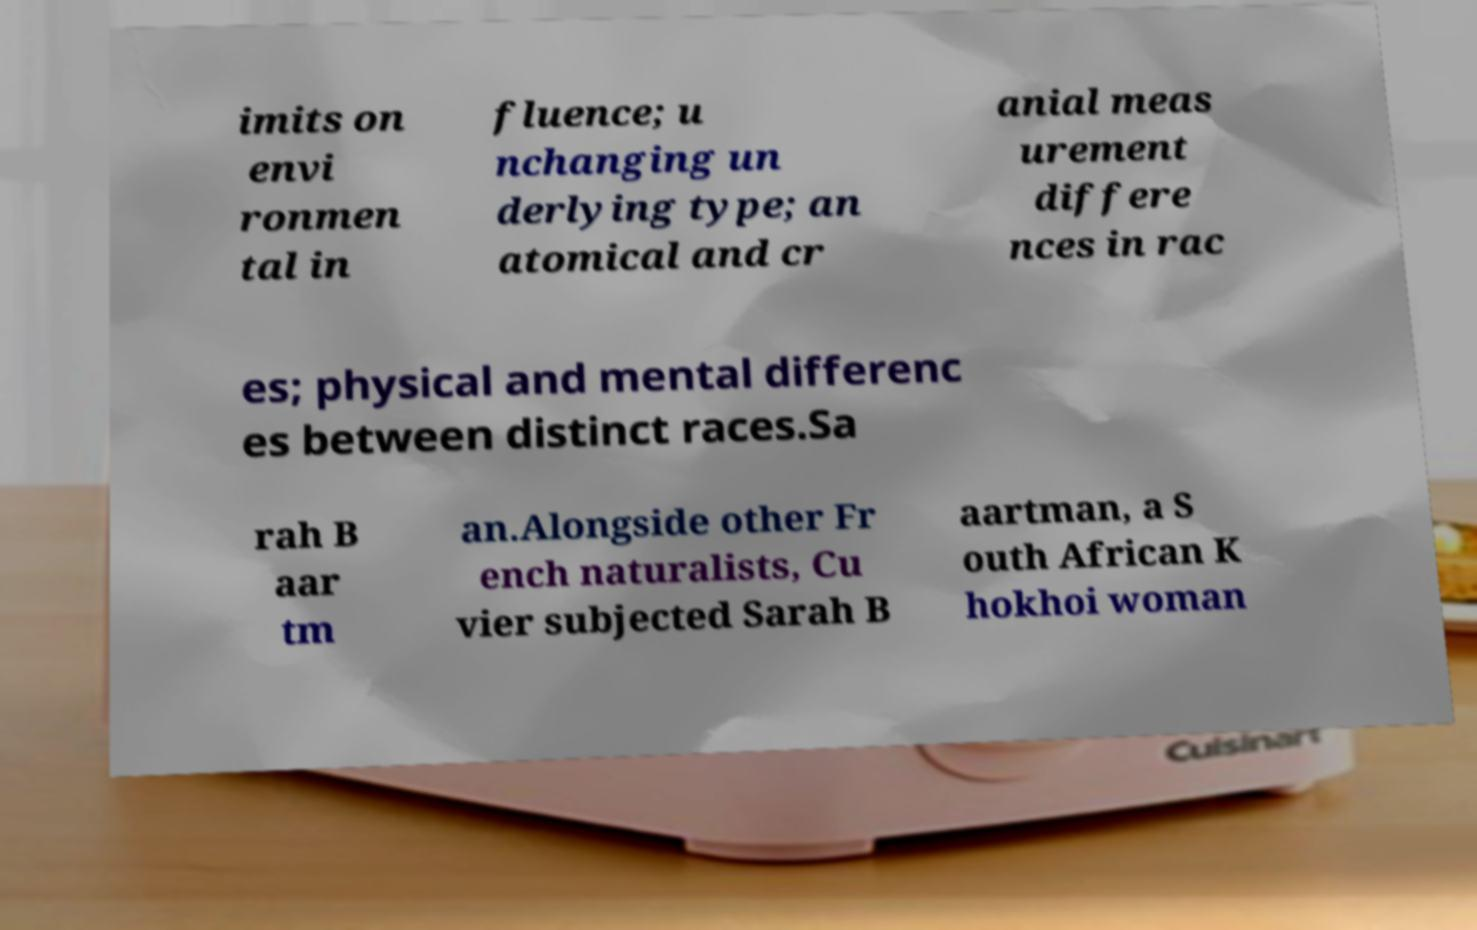Could you extract and type out the text from this image? imits on envi ronmen tal in fluence; u nchanging un derlying type; an atomical and cr anial meas urement differe nces in rac es; physical and mental differenc es between distinct races.Sa rah B aar tm an.Alongside other Fr ench naturalists, Cu vier subjected Sarah B aartman, a S outh African K hokhoi woman 